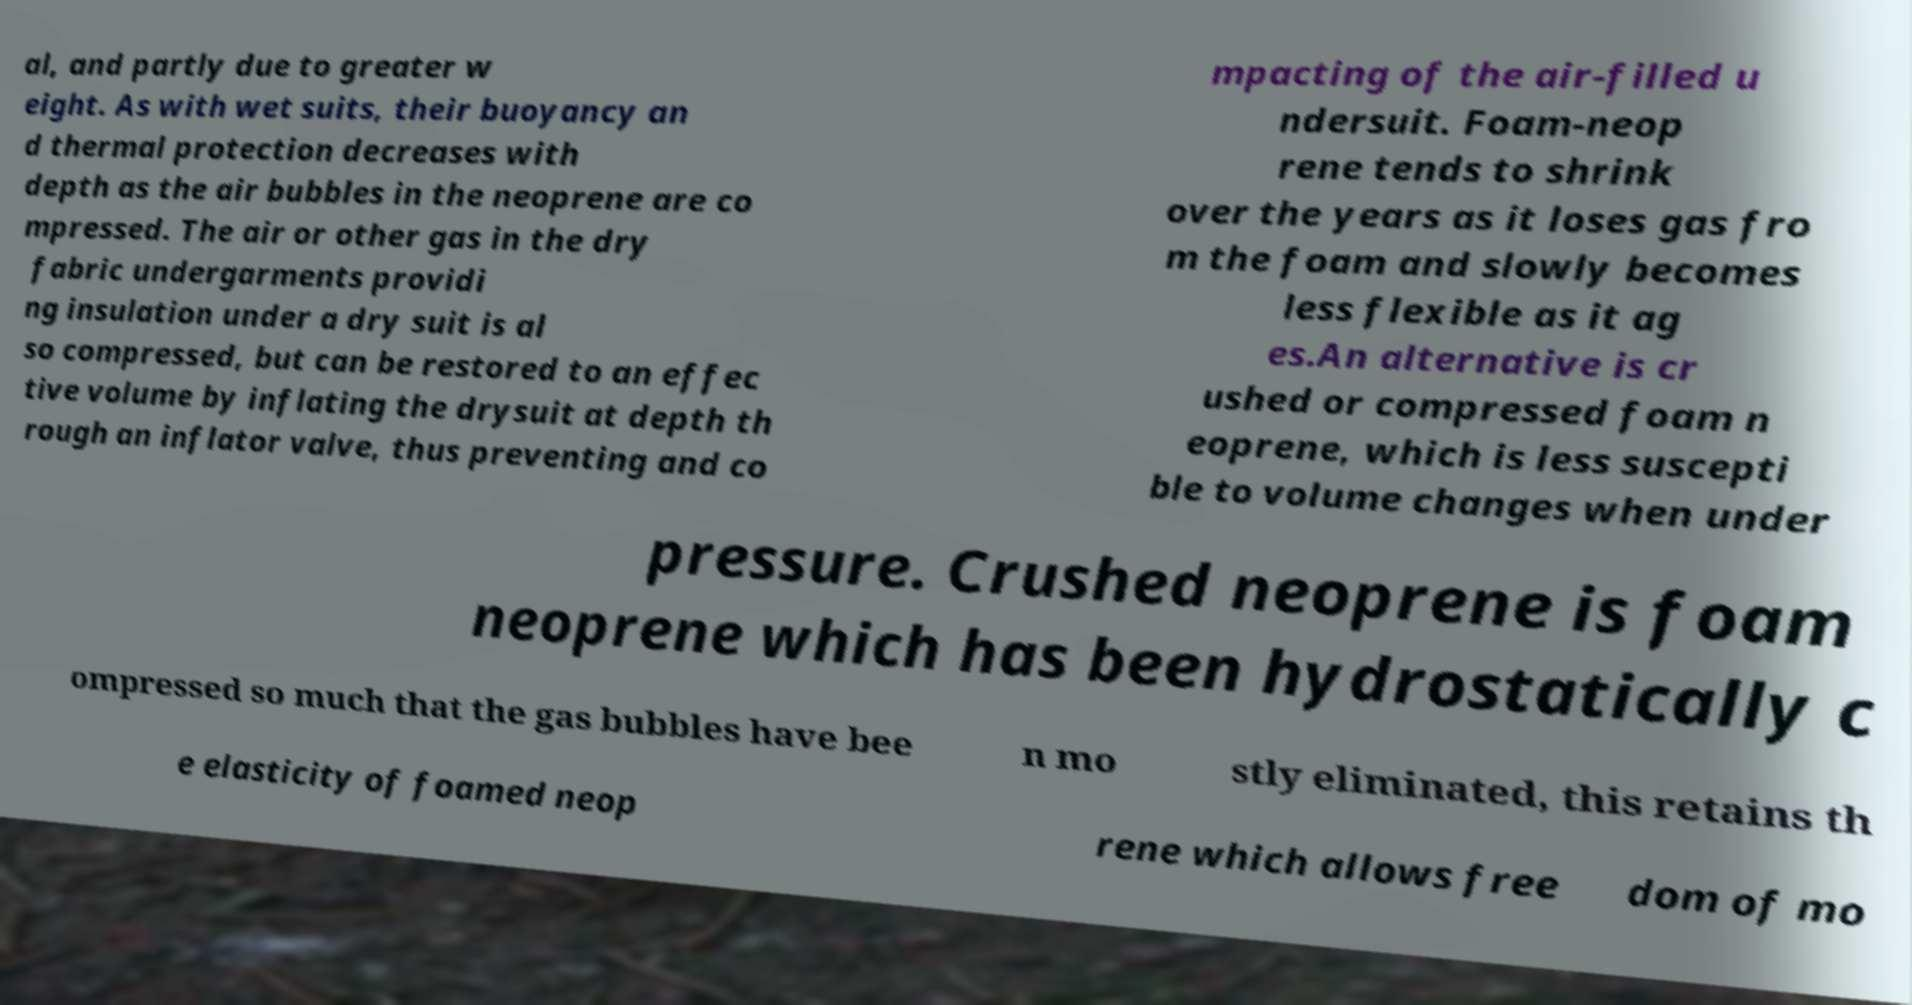Can you accurately transcribe the text from the provided image for me? al, and partly due to greater w eight. As with wet suits, their buoyancy an d thermal protection decreases with depth as the air bubbles in the neoprene are co mpressed. The air or other gas in the dry fabric undergarments providi ng insulation under a dry suit is al so compressed, but can be restored to an effec tive volume by inflating the drysuit at depth th rough an inflator valve, thus preventing and co mpacting of the air-filled u ndersuit. Foam-neop rene tends to shrink over the years as it loses gas fro m the foam and slowly becomes less flexible as it ag es.An alternative is cr ushed or compressed foam n eoprene, which is less suscepti ble to volume changes when under pressure. Crushed neoprene is foam neoprene which has been hydrostatically c ompressed so much that the gas bubbles have bee n mo stly eliminated, this retains th e elasticity of foamed neop rene which allows free dom of mo 